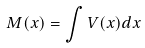Convert formula to latex. <formula><loc_0><loc_0><loc_500><loc_500>M ( x ) = \int V ( x ) d x</formula> 